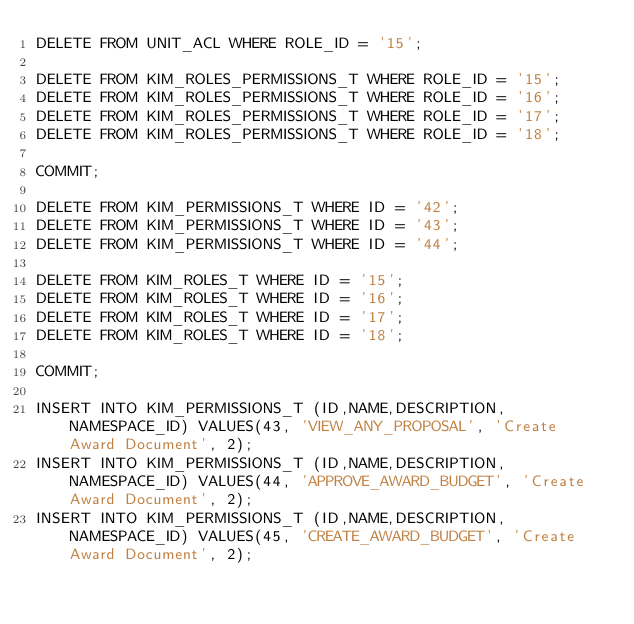<code> <loc_0><loc_0><loc_500><loc_500><_SQL_>DELETE FROM UNIT_ACL WHERE ROLE_ID = '15';

DELETE FROM KIM_ROLES_PERMISSIONS_T WHERE ROLE_ID = '15';
DELETE FROM KIM_ROLES_PERMISSIONS_T WHERE ROLE_ID = '16';
DELETE FROM KIM_ROLES_PERMISSIONS_T WHERE ROLE_ID = '17';
DELETE FROM KIM_ROLES_PERMISSIONS_T WHERE ROLE_ID = '18';

COMMIT;

DELETE FROM KIM_PERMISSIONS_T WHERE ID = '42';
DELETE FROM KIM_PERMISSIONS_T WHERE ID = '43';
DELETE FROM KIM_PERMISSIONS_T WHERE ID = '44';

DELETE FROM KIM_ROLES_T WHERE ID = '15';
DELETE FROM KIM_ROLES_T WHERE ID = '16';
DELETE FROM KIM_ROLES_T WHERE ID = '17';
DELETE FROM KIM_ROLES_T WHERE ID = '18';

COMMIT;

INSERT INTO KIM_PERMISSIONS_T (ID,NAME,DESCRIPTION,NAMESPACE_ID) VALUES(43, 'VIEW_ANY_PROPOSAL', 'Create Award Document', 2);
INSERT INTO KIM_PERMISSIONS_T (ID,NAME,DESCRIPTION,NAMESPACE_ID) VALUES(44, 'APPROVE_AWARD_BUDGET', 'Create Award Document', 2);
INSERT INTO KIM_PERMISSIONS_T (ID,NAME,DESCRIPTION,NAMESPACE_ID) VALUES(45, 'CREATE_AWARD_BUDGET', 'Create Award Document', 2);</code> 